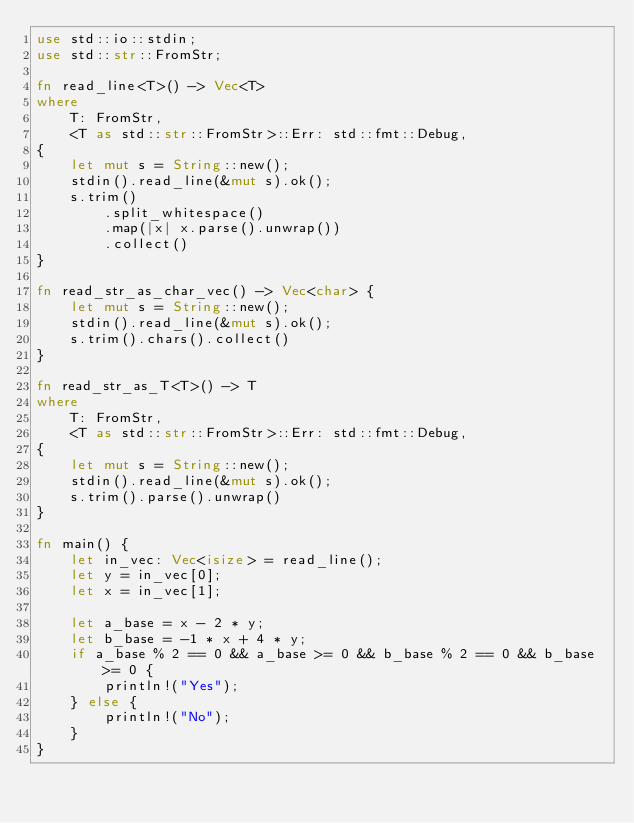<code> <loc_0><loc_0><loc_500><loc_500><_Rust_>use std::io::stdin;
use std::str::FromStr;

fn read_line<T>() -> Vec<T>
where
    T: FromStr,
    <T as std::str::FromStr>::Err: std::fmt::Debug,
{
    let mut s = String::new();
    stdin().read_line(&mut s).ok();
    s.trim()
        .split_whitespace()
        .map(|x| x.parse().unwrap())
        .collect()
}

fn read_str_as_char_vec() -> Vec<char> {
    let mut s = String::new();
    stdin().read_line(&mut s).ok();
    s.trim().chars().collect()
}

fn read_str_as_T<T>() -> T
where
    T: FromStr,
    <T as std::str::FromStr>::Err: std::fmt::Debug,
{
    let mut s = String::new();
    stdin().read_line(&mut s).ok();
    s.trim().parse().unwrap()
}

fn main() {
    let in_vec: Vec<isize> = read_line();
    let y = in_vec[0];
    let x = in_vec[1];

    let a_base = x - 2 * y;
    let b_base = -1 * x + 4 * y;
    if a_base % 2 == 0 && a_base >= 0 && b_base % 2 == 0 && b_base >= 0 {
        println!("Yes");
    } else {
        println!("No");
    }
}
</code> 